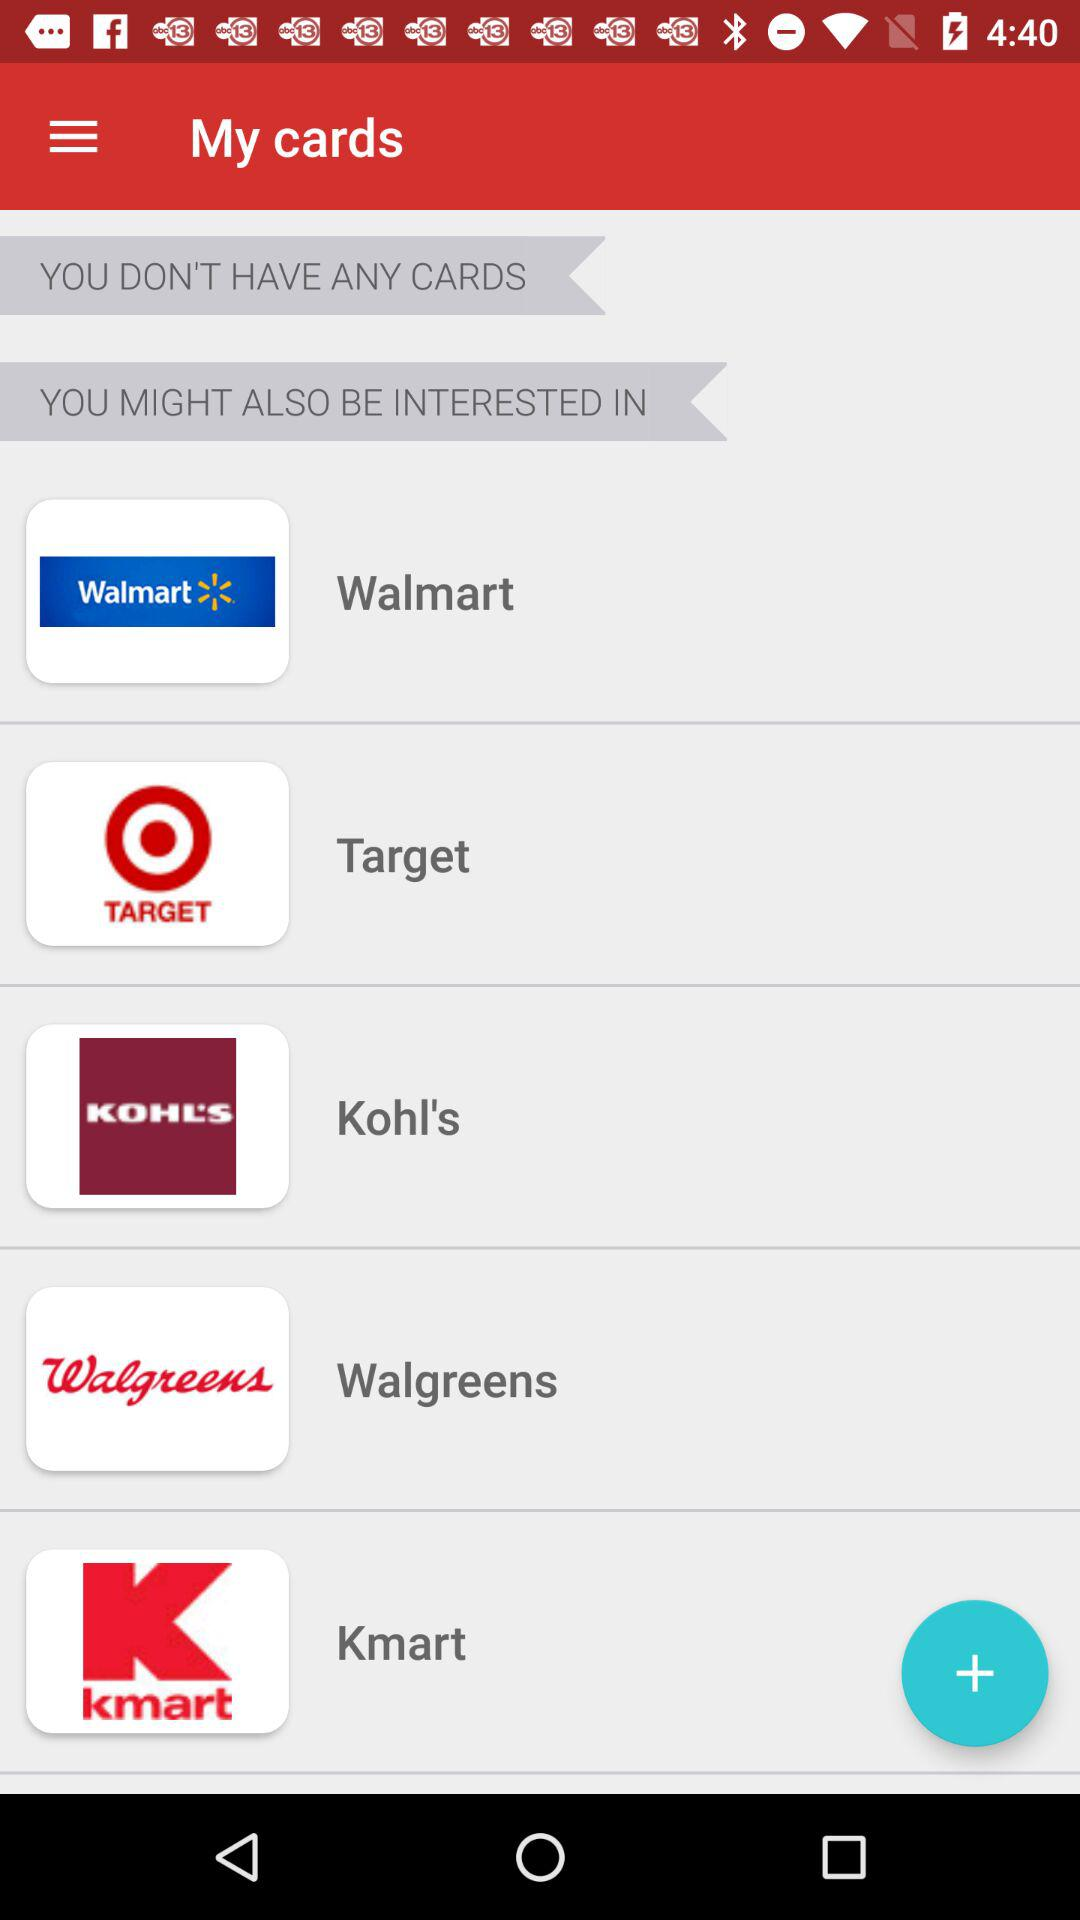Which companies are selected?
When the provided information is insufficient, respond with <no answer>. <no answer> 